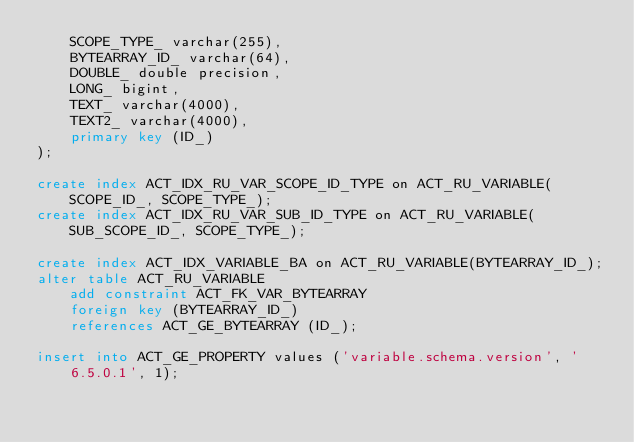<code> <loc_0><loc_0><loc_500><loc_500><_SQL_>    SCOPE_TYPE_ varchar(255),
    BYTEARRAY_ID_ varchar(64),
    DOUBLE_ double precision,
    LONG_ bigint,
    TEXT_ varchar(4000),
    TEXT2_ varchar(4000),
    primary key (ID_)
);

create index ACT_IDX_RU_VAR_SCOPE_ID_TYPE on ACT_RU_VARIABLE(SCOPE_ID_, SCOPE_TYPE_);
create index ACT_IDX_RU_VAR_SUB_ID_TYPE on ACT_RU_VARIABLE(SUB_SCOPE_ID_, SCOPE_TYPE_);

create index ACT_IDX_VARIABLE_BA on ACT_RU_VARIABLE(BYTEARRAY_ID_);
alter table ACT_RU_VARIABLE 
    add constraint ACT_FK_VAR_BYTEARRAY 
    foreign key (BYTEARRAY_ID_) 
    references ACT_GE_BYTEARRAY (ID_);

insert into ACT_GE_PROPERTY values ('variable.schema.version', '6.5.0.1', 1);</code> 